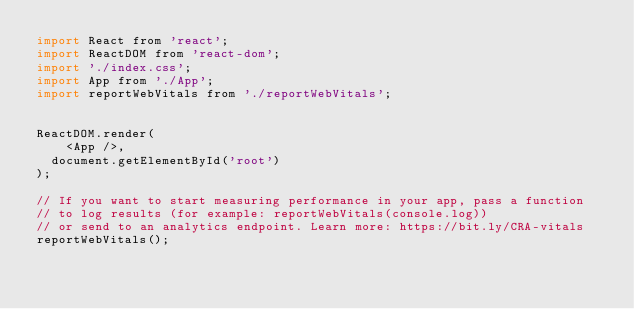Convert code to text. <code><loc_0><loc_0><loc_500><loc_500><_JavaScript_>import React from 'react';
import ReactDOM from 'react-dom';
import './index.css';
import App from './App';
import reportWebVitals from './reportWebVitals';


ReactDOM.render(
    <App />,
  document.getElementById('root')
);

// If you want to start measuring performance in your app, pass a function
// to log results (for example: reportWebVitals(console.log))
// or send to an analytics endpoint. Learn more: https://bit.ly/CRA-vitals
reportWebVitals();
</code> 